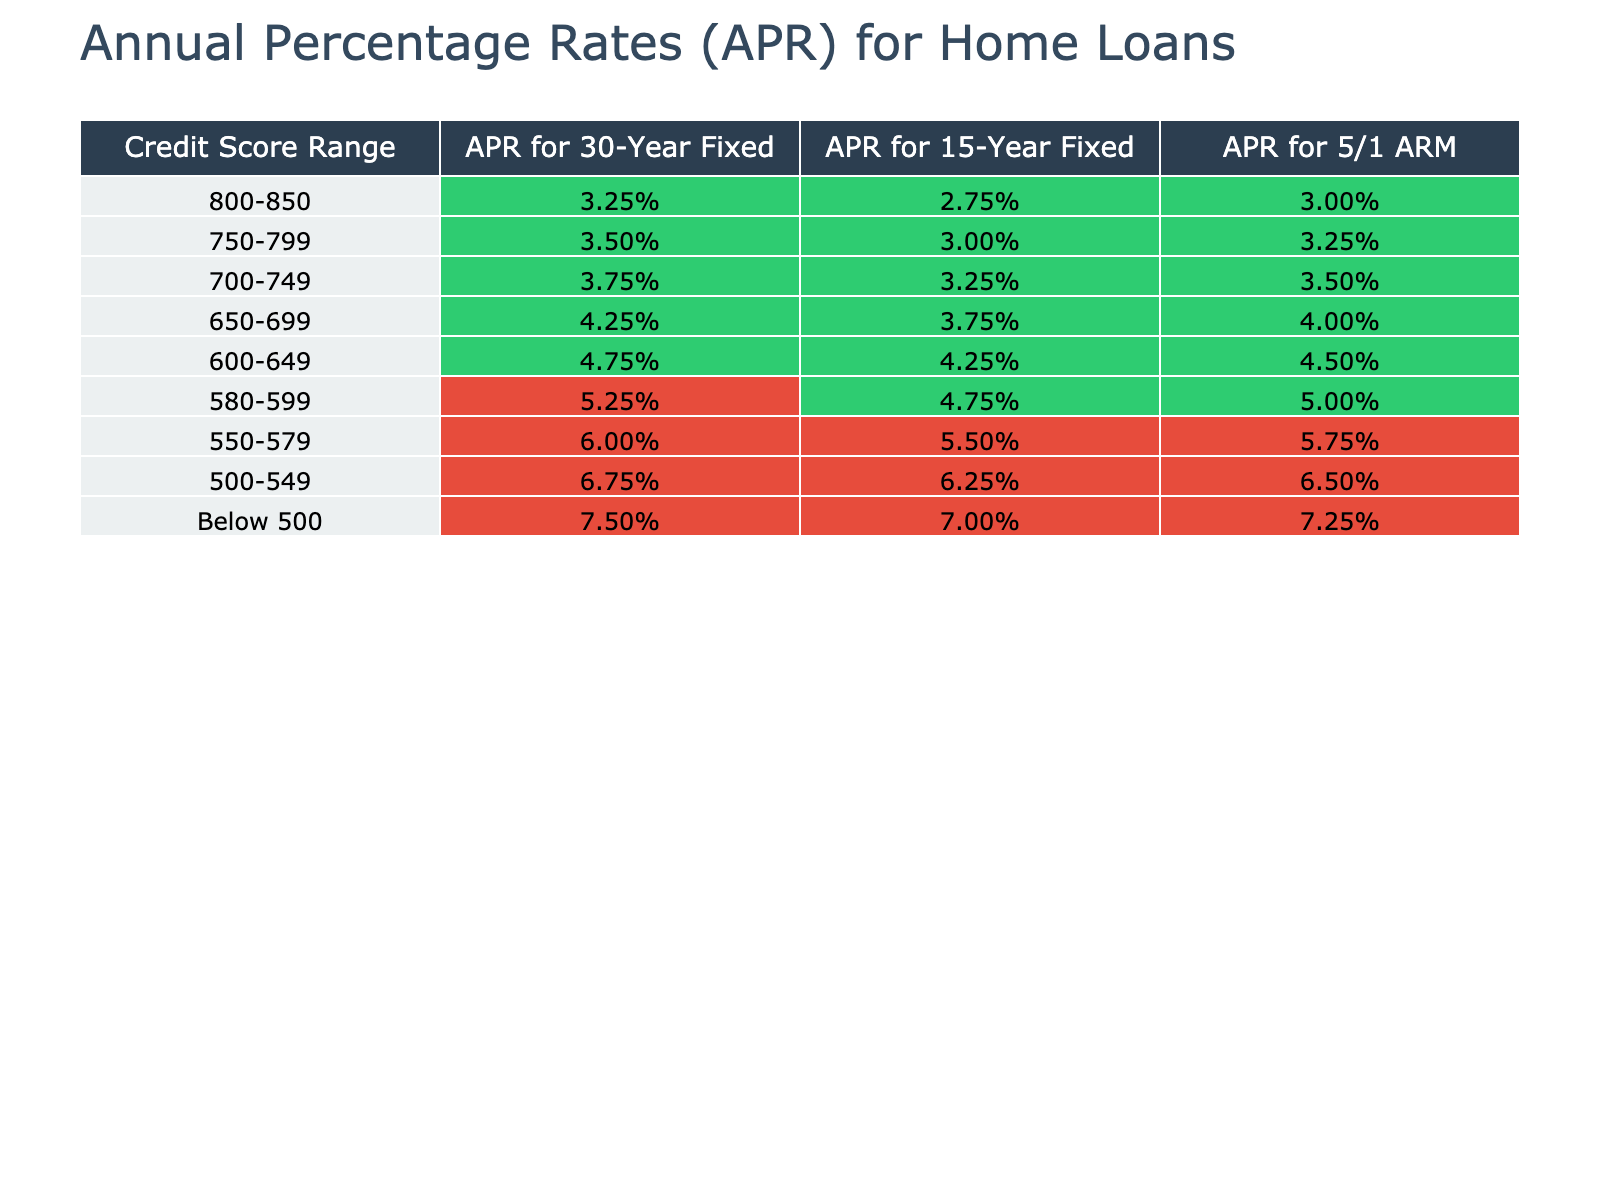What is the APR for a 30-Year Fixed loan for borrowers with a credit score of 700-749? According to the table, borrowers in the 700-749 credit score range have an APR of 3.75% for a 30-Year Fixed loan.
Answer: 3.75% What is the difference in APR between the 15-Year Fixed loan and the 5/1 ARM for borrowers with a credit score between 650-699? For the 650-699 credit score range, the APR for a 15-Year Fixed loan is 3.75% and for a 5/1 ARM it is 4.00%. The difference is 4.00% - 3.75% = 0.25%.
Answer: 0.25% Is the APR for a 5/1 ARM higher for borrowers with a credit score of 580-599 compared to those with a score of 600-649? The APR for a 5/1 ARM for borrowers with a credit score of 580-599 is 5.00%, whereas for borrowers with a credit score of 600-649 it is 4.50%. Therefore, it is higher for the 580-599 range.
Answer: Yes What is the average APR for the 30-Year Fixed loans across all credit score ranges? To find the average, we sum the APRs for 30-Year Fixed loans: 3.25% + 3.50% + 3.75% + 4.25% + 4.75% + 5.25% + 6.00% + 6.75% + 7.50% = 45.00%, and then divide by 9 (the number of groups), resulting in an average of 5.00%.
Answer: 5.00% Which credit score range has the lowest APR for a 15-Year Fixed loan? The credit score range with the lowest APR for a 15-Year Fixed loan is 800-850, which has an APR of 2.75%.
Answer: 800-850 If a borrower has a credit score of 500-549, what is the difference in APR between a 30-Year Fixed loan and a 15-Year Fixed loan? For a borrower with a credit score of 500-549, the APR for a 30-Year Fixed loan is 6.75% and for a 15-Year Fixed loan it is 6.25%. The difference is 6.75% - 6.25% = 0.50%.
Answer: 0.50% What is the APR for a 5/1 ARM for borrowers with a credit score below 500? According to the table, borrowers with a credit score below 500 have an APR of 7.25% for a 5/1 ARM.
Answer: 7.25% Is the APR for a 30-Year Fixed loan higher for borrowers with a credit score of 650-699 compared to those with a score of 700-749? The APR for a 30-Year Fixed loan for 650-699 range is 4.25%, while for 700-749 it is 3.75%. Since 4.25% is higher than 3.75%, the statement is true.
Answer: Yes What is the total APR for both a 15-Year Fixed and 5/1 ARM loan for borrowers with a credit score of 580-599? For the 580-599 range, the APR for a 15-Year Fixed loan is 4.75% and for a 5/1 ARM it is 5.00%. The total is 4.75% + 5.00% = 9.75%.
Answer: 9.75% 